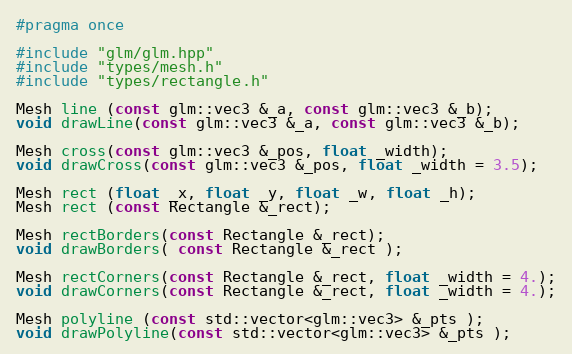<code> <loc_0><loc_0><loc_500><loc_500><_C_>#pragma once

#include "glm/glm.hpp"
#include "types/mesh.h"
#include "types/rectangle.h"

Mesh line (const glm::vec3 &_a, const glm::vec3 &_b);
void drawLine(const glm::vec3 &_a, const glm::vec3 &_b);

Mesh cross(const glm::vec3 &_pos, float _width);
void drawCross(const glm::vec3 &_pos, float _width = 3.5);

Mesh rect (float _x, float _y, float _w, float _h);
Mesh rect (const Rectangle &_rect);

Mesh rectBorders(const Rectangle &_rect);
void drawBorders( const Rectangle &_rect );

Mesh rectCorners(const Rectangle &_rect, float _width = 4.);
void drawCorners(const Rectangle &_rect, float _width = 4.);

Mesh polyline (const std::vector<glm::vec3> &_pts );
void drawPolyline(const std::vector<glm::vec3> &_pts );</code> 